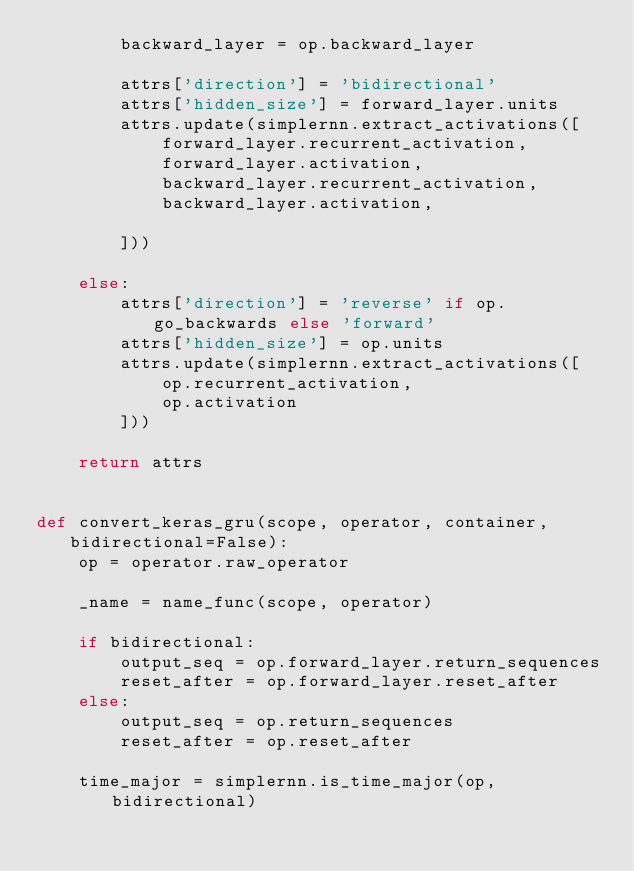Convert code to text. <code><loc_0><loc_0><loc_500><loc_500><_Python_>        backward_layer = op.backward_layer

        attrs['direction'] = 'bidirectional'
        attrs['hidden_size'] = forward_layer.units
        attrs.update(simplernn.extract_activations([
            forward_layer.recurrent_activation,
            forward_layer.activation,
            backward_layer.recurrent_activation,
            backward_layer.activation,

        ]))

    else:
        attrs['direction'] = 'reverse' if op.go_backwards else 'forward'
        attrs['hidden_size'] = op.units
        attrs.update(simplernn.extract_activations([
            op.recurrent_activation,
            op.activation
        ]))

    return attrs


def convert_keras_gru(scope, operator, container, bidirectional=False):
    op = operator.raw_operator

    _name = name_func(scope, operator)

    if bidirectional:
        output_seq = op.forward_layer.return_sequences
        reset_after = op.forward_layer.reset_after
    else:
        output_seq = op.return_sequences
        reset_after = op.reset_after

    time_major = simplernn.is_time_major(op, bidirectional)
</code> 